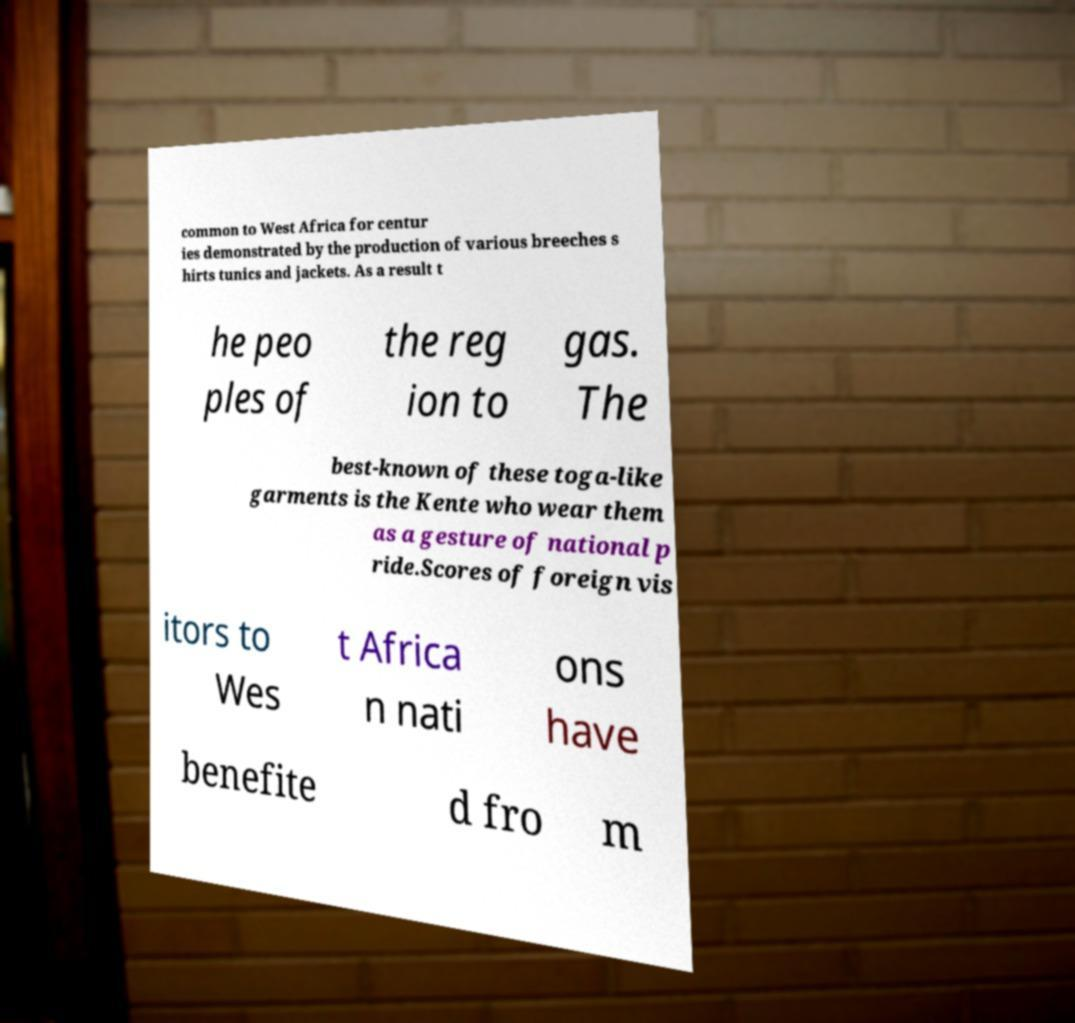Could you assist in decoding the text presented in this image and type it out clearly? common to West Africa for centur ies demonstrated by the production of various breeches s hirts tunics and jackets. As a result t he peo ples of the reg ion to gas. The best-known of these toga-like garments is the Kente who wear them as a gesture of national p ride.Scores of foreign vis itors to Wes t Africa n nati ons have benefite d fro m 